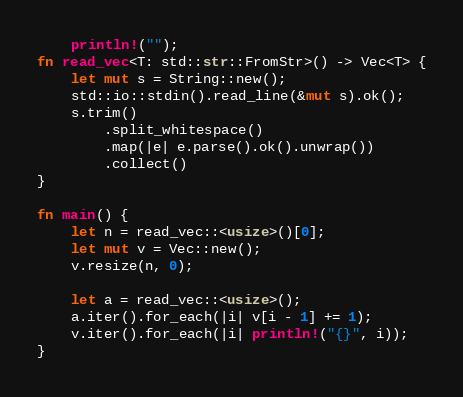Convert code to text. <code><loc_0><loc_0><loc_500><loc_500><_Rust_>    println!("");
fn read_vec<T: std::str::FromStr>() -> Vec<T> {
    let mut s = String::new();
    std::io::stdin().read_line(&mut s).ok();
    s.trim()
        .split_whitespace()
        .map(|e| e.parse().ok().unwrap())
        .collect()
}

fn main() {
    let n = read_vec::<usize>()[0];
    let mut v = Vec::new();
    v.resize(n, 0);

    let a = read_vec::<usize>();
    a.iter().for_each(|i| v[i - 1] += 1);
    v.iter().for_each(|i| println!("{}", i));
}
</code> 